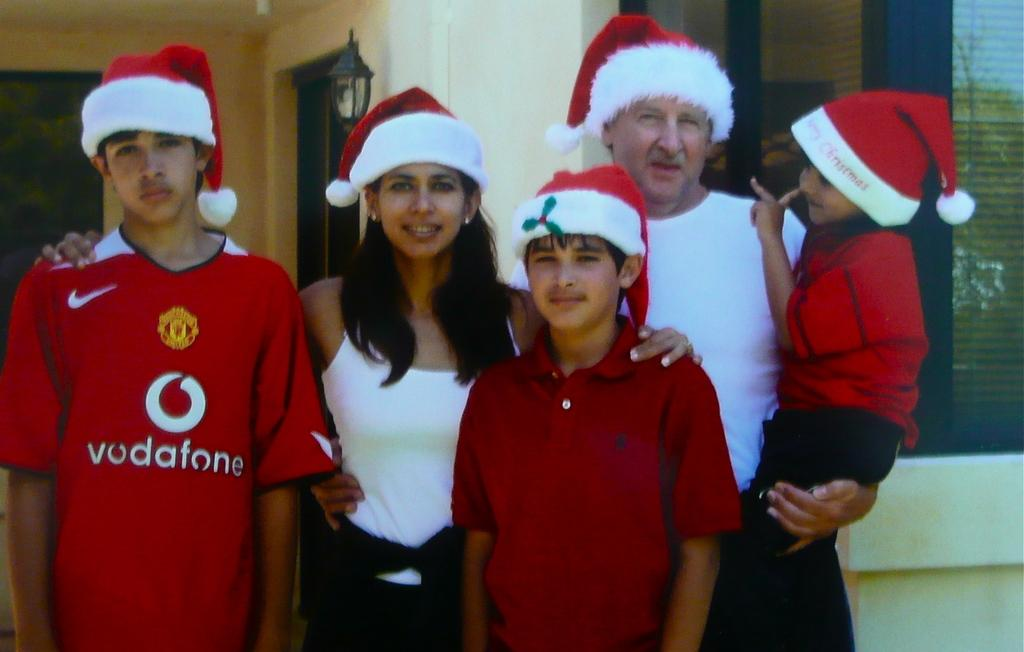<image>
Share a concise interpretation of the image provided. A family of five wearing Santa hats pose for a picture with the oldest child wearing a vodafone Nike jersey. 